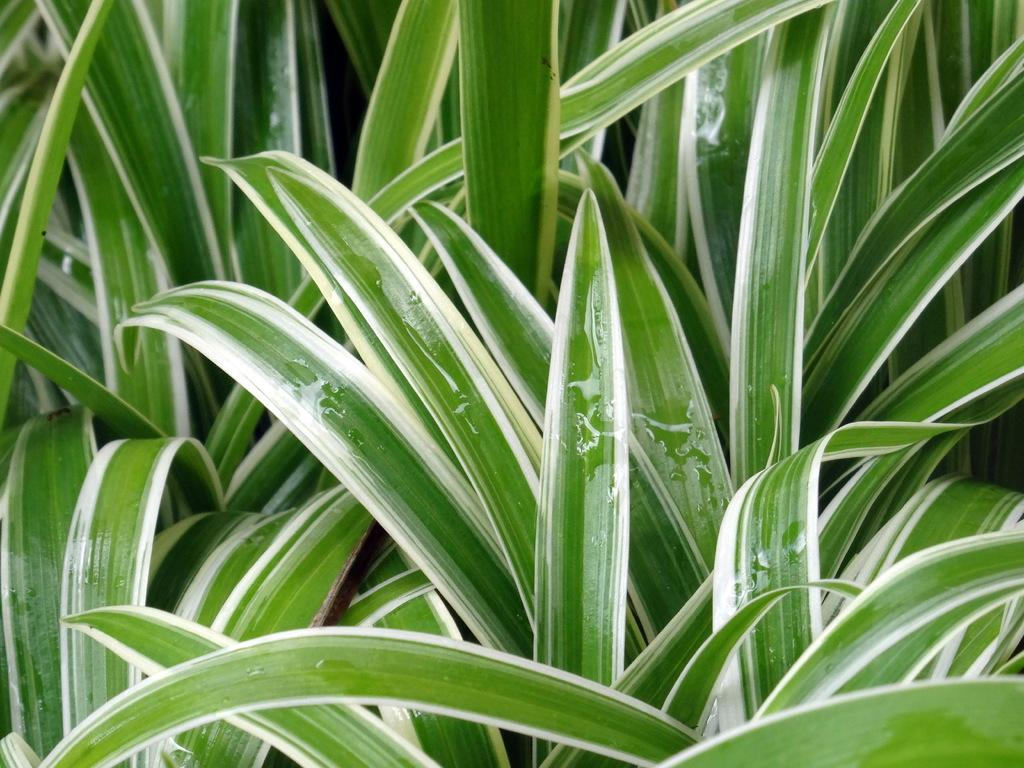What is present in the image? There are plants in the image. Can you describe the plants in more detail? Yes, there are water droplets on the leaves of the plants. What type of skirt can be seen on the edge of the image? There is no skirt present in the image; it only features plants with water droplets on their leaves. 